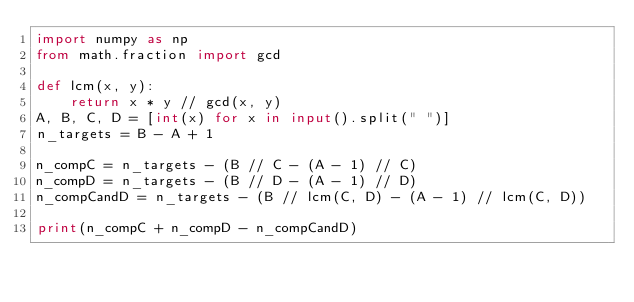Convert code to text. <code><loc_0><loc_0><loc_500><loc_500><_Python_>import numpy as np
from math.fraction import gcd

def lcm(x, y):
    return x * y // gcd(x, y)
A, B, C, D = [int(x) for x in input().split(" ")]
n_targets = B - A + 1

n_compC = n_targets - (B // C - (A - 1) // C)
n_compD = n_targets - (B // D - (A - 1) // D)
n_compCandD = n_targets - (B // lcm(C, D) - (A - 1) // lcm(C, D))

print(n_compC + n_compD - n_compCandD)</code> 